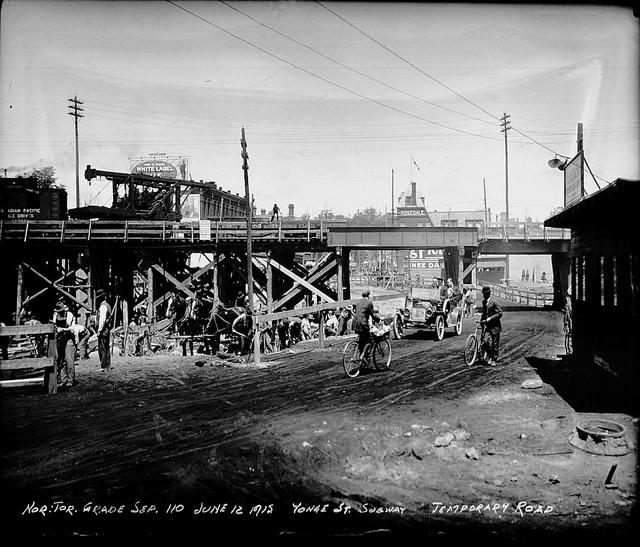What is near the car?

Choices:
A) bison
B) museum
C) bicycles
D) apple pie bicycles 